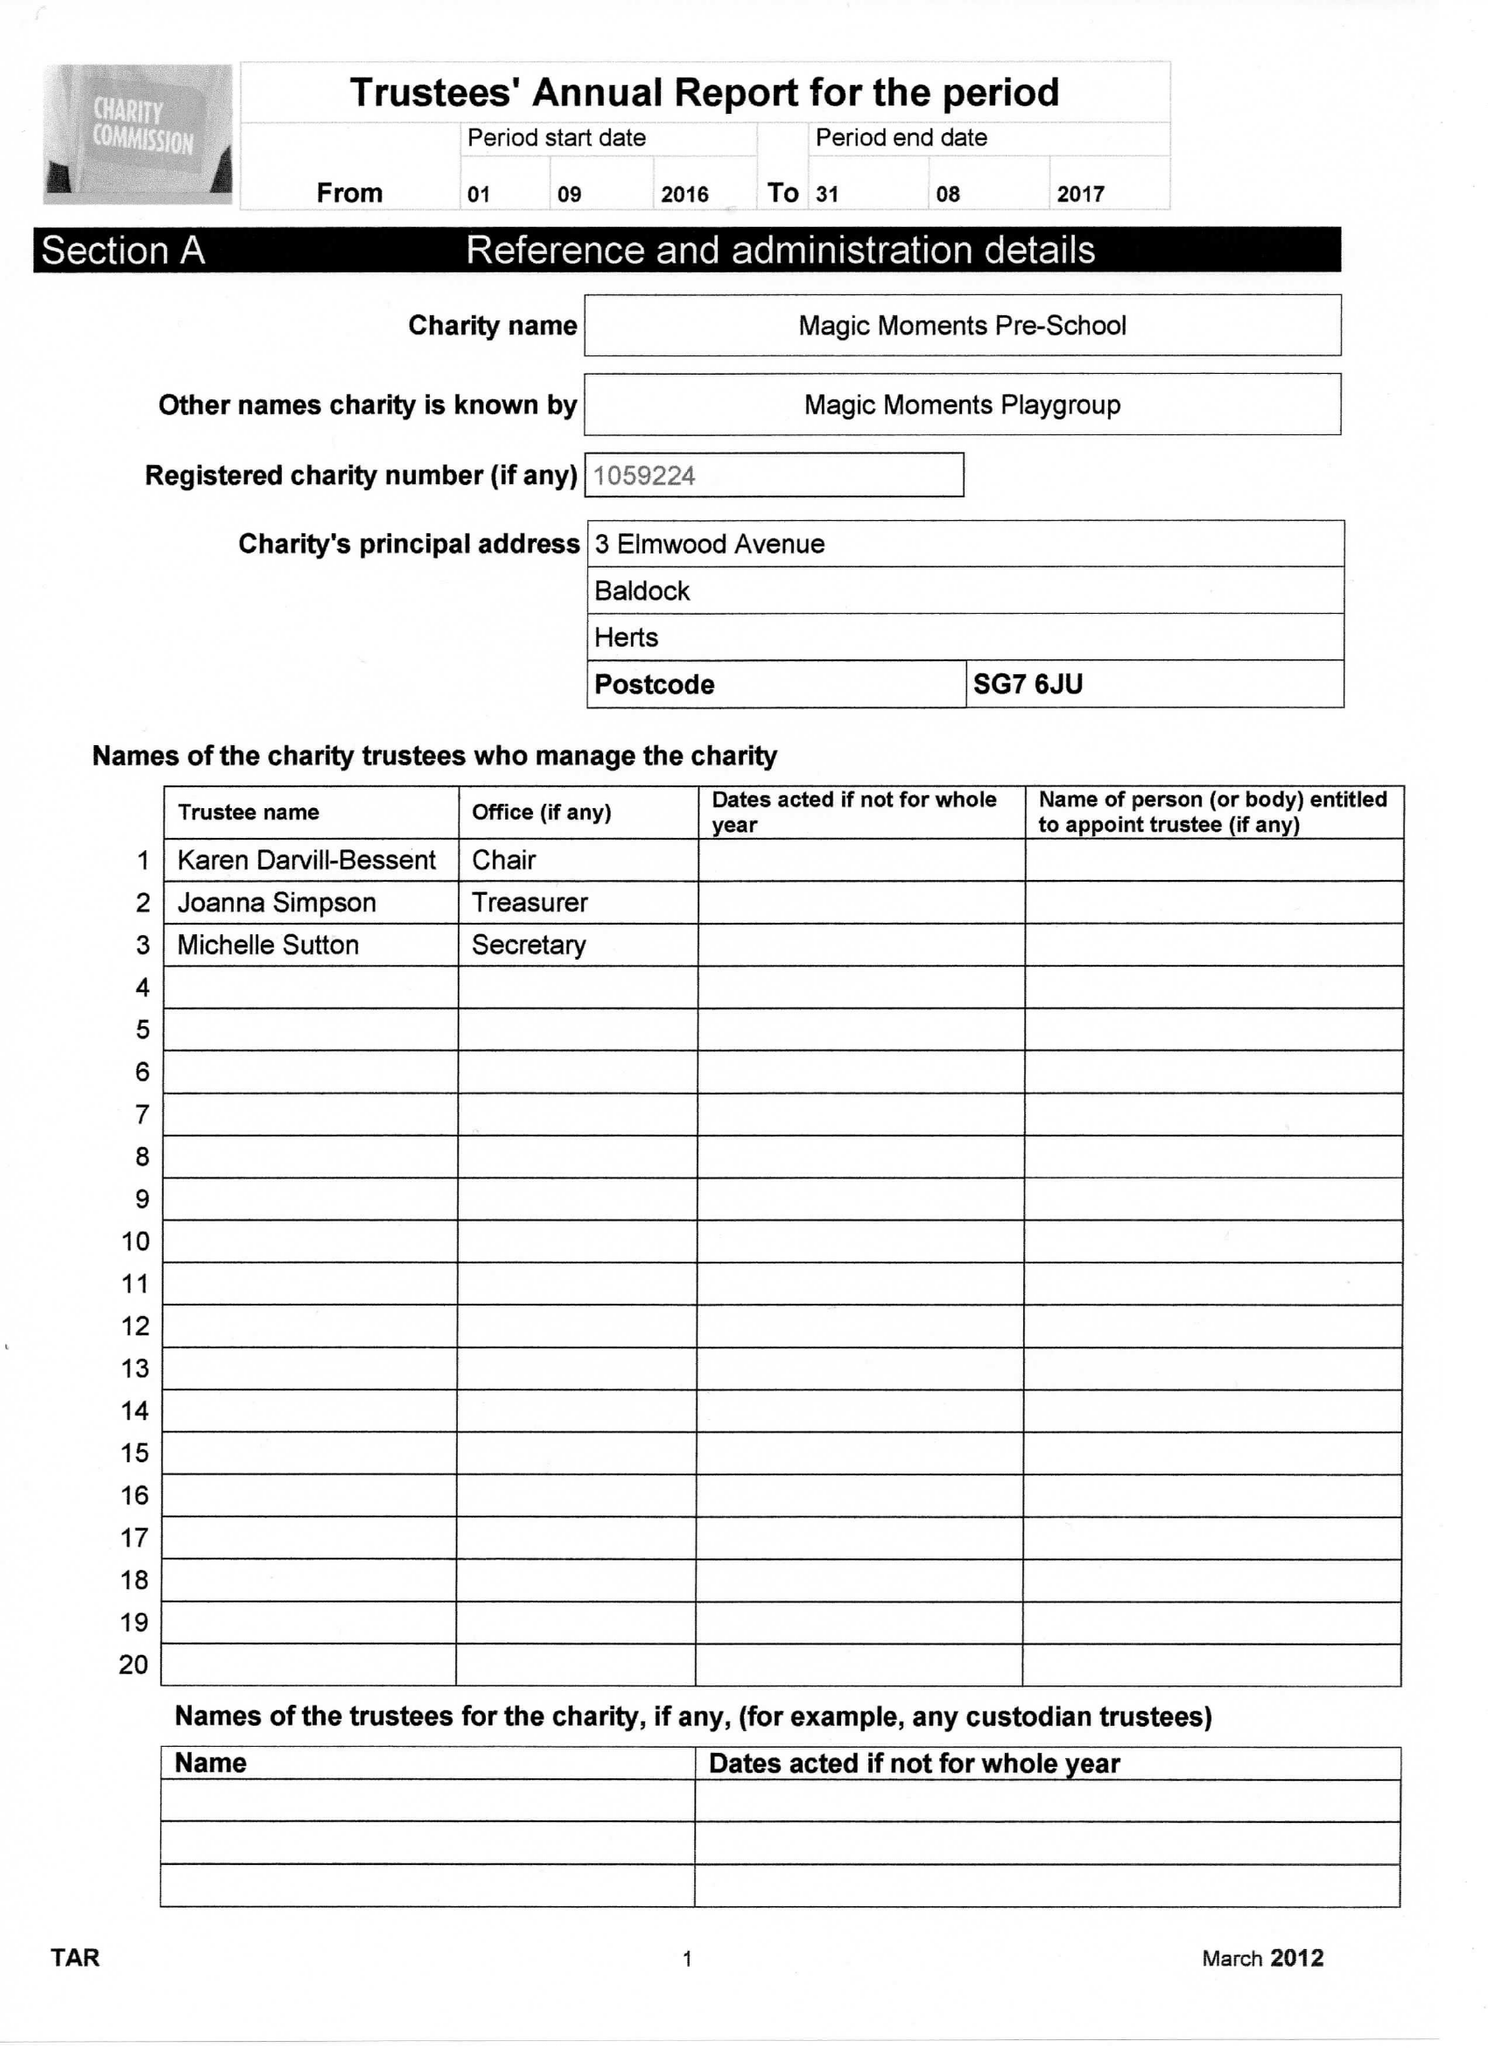What is the value for the report_date?
Answer the question using a single word or phrase. 2017-08-31 